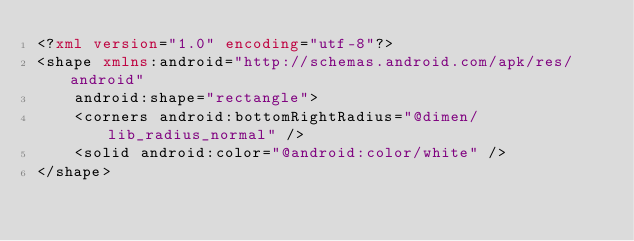Convert code to text. <code><loc_0><loc_0><loc_500><loc_500><_XML_><?xml version="1.0" encoding="utf-8"?>
<shape xmlns:android="http://schemas.android.com/apk/res/android"
    android:shape="rectangle">
    <corners android:bottomRightRadius="@dimen/lib_radius_normal" />
    <solid android:color="@android:color/white" />
</shape>
</code> 